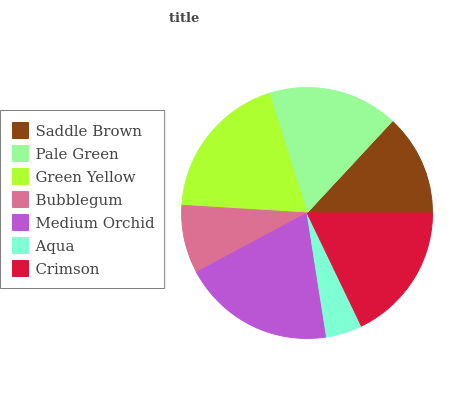Is Aqua the minimum?
Answer yes or no. Yes. Is Medium Orchid the maximum?
Answer yes or no. Yes. Is Pale Green the minimum?
Answer yes or no. No. Is Pale Green the maximum?
Answer yes or no. No. Is Pale Green greater than Saddle Brown?
Answer yes or no. Yes. Is Saddle Brown less than Pale Green?
Answer yes or no. Yes. Is Saddle Brown greater than Pale Green?
Answer yes or no. No. Is Pale Green less than Saddle Brown?
Answer yes or no. No. Is Pale Green the high median?
Answer yes or no. Yes. Is Pale Green the low median?
Answer yes or no. Yes. Is Green Yellow the high median?
Answer yes or no. No. Is Medium Orchid the low median?
Answer yes or no. No. 